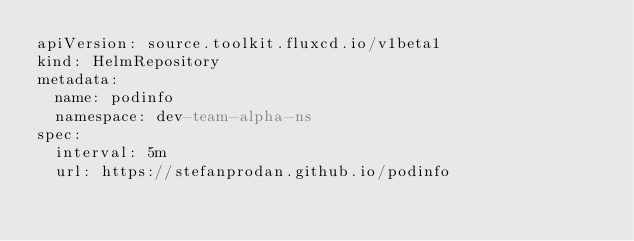<code> <loc_0><loc_0><loc_500><loc_500><_YAML_>apiVersion: source.toolkit.fluxcd.io/v1beta1
kind: HelmRepository
metadata:
  name: podinfo
  namespace: dev-team-alpha-ns
spec:
  interval: 5m
  url: https://stefanprodan.github.io/podinfo
</code> 